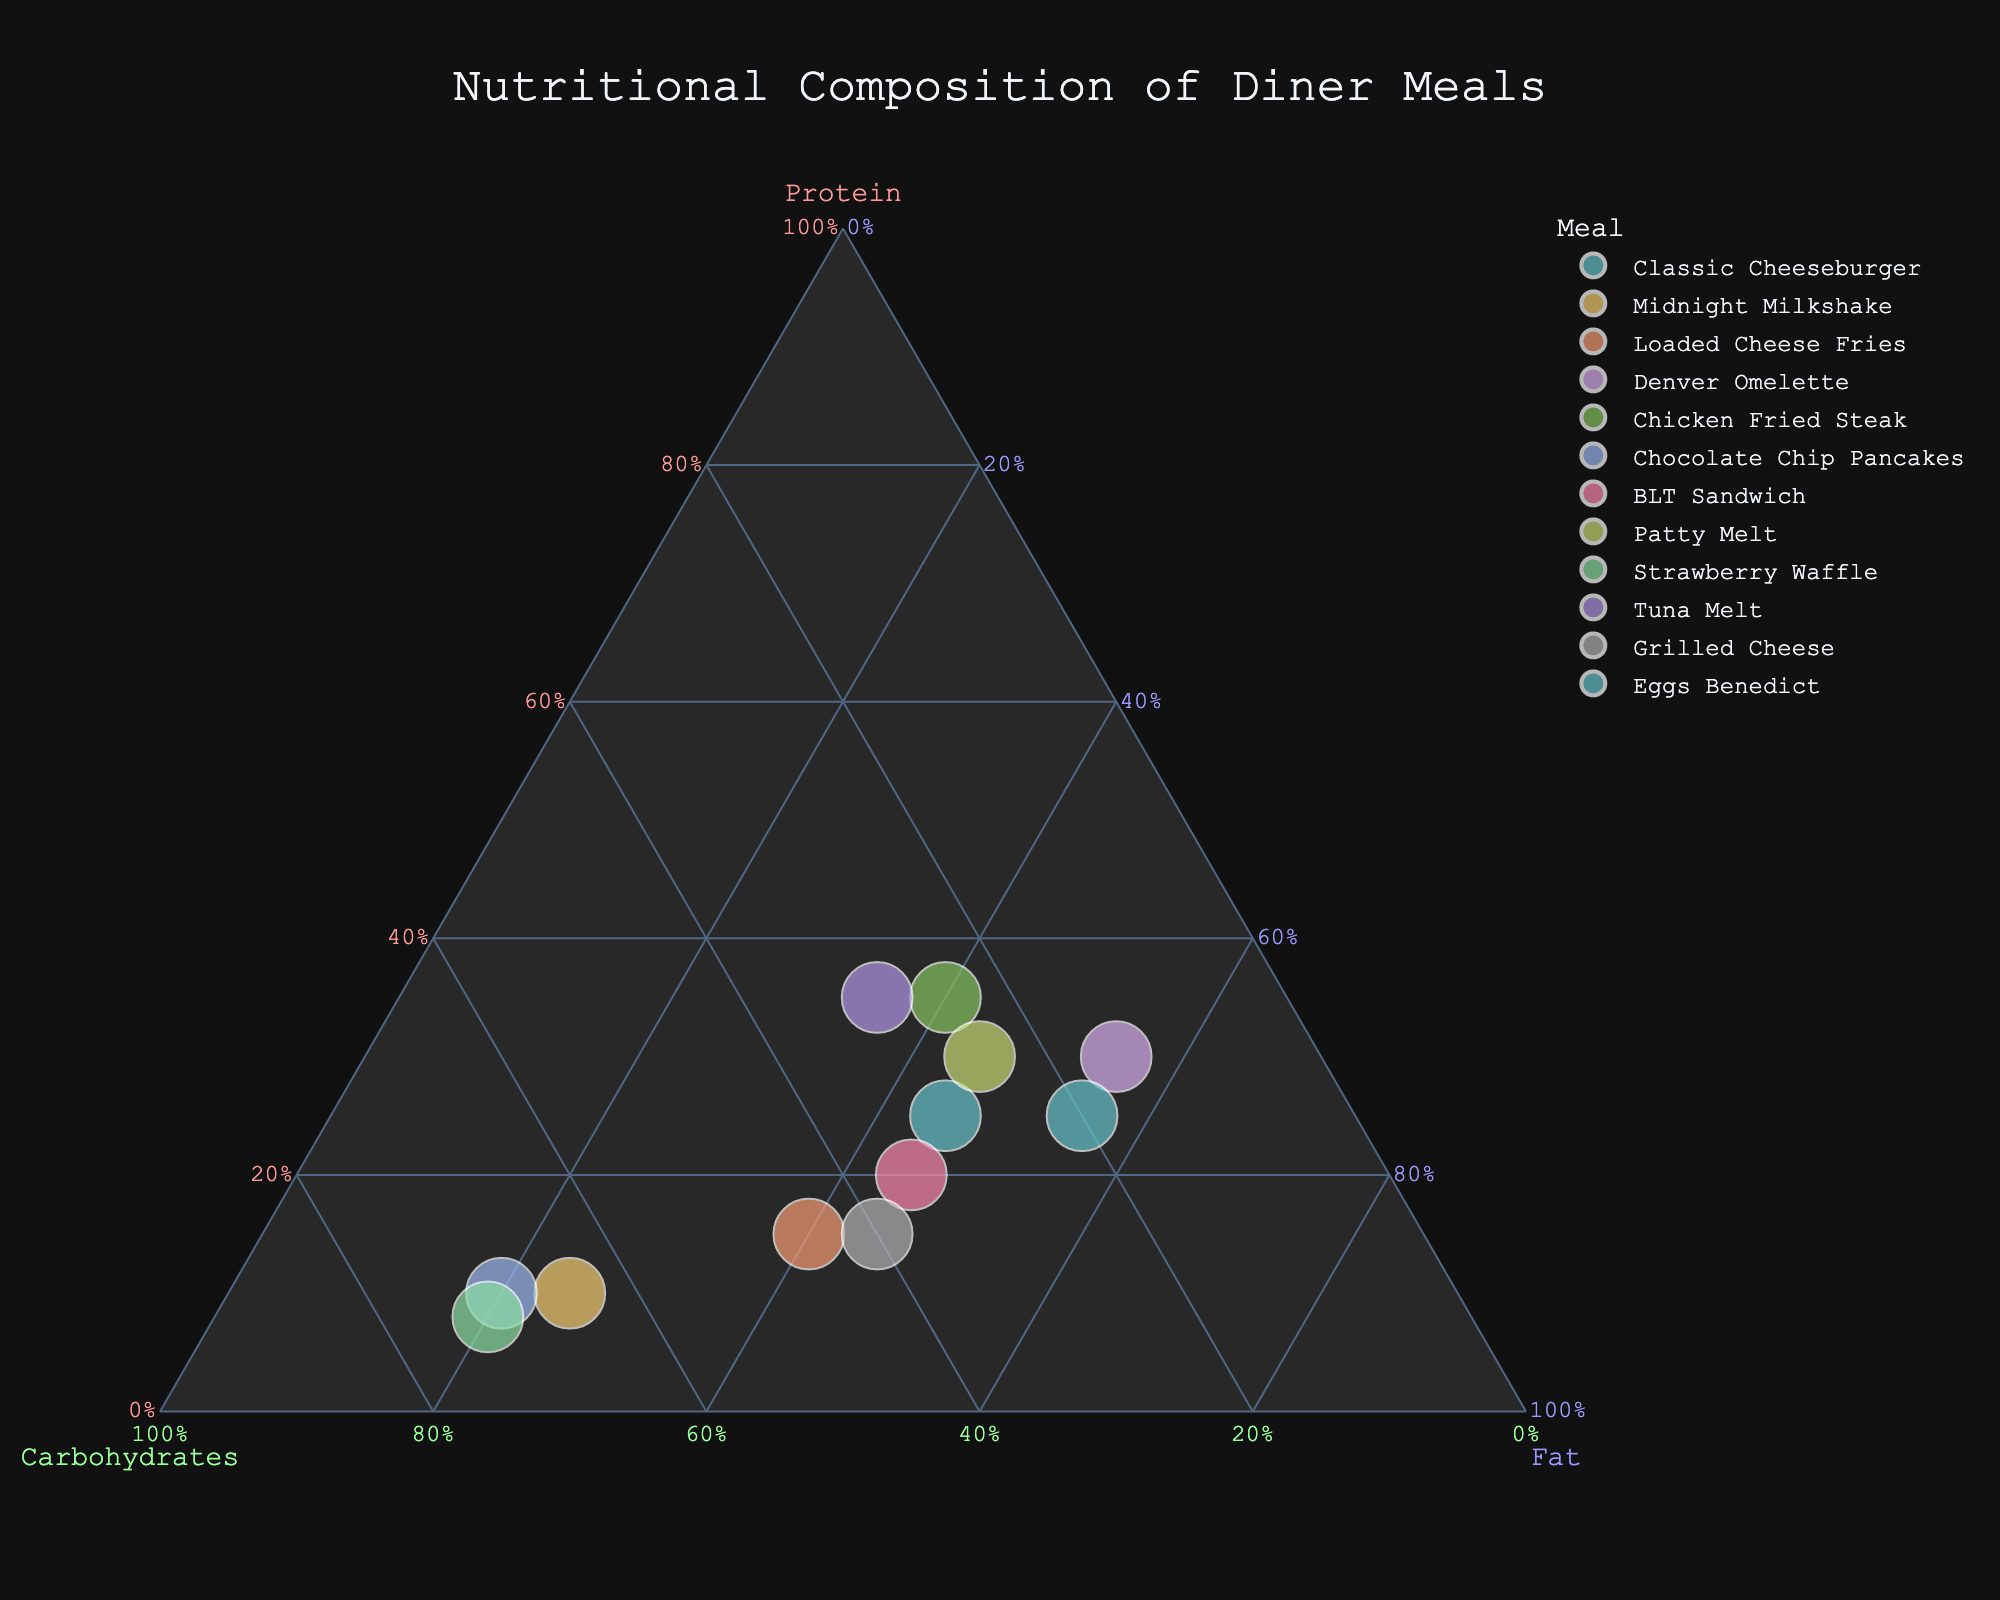What's the title of the plot? The title is displayed prominently at the top of the figure. It summarizes the overall subject of the plot, making it easy to identify the theme of the visualization.
Answer: Nutritional Composition of Diner Meals How many meals are represented on the plot? Each meal corresponds to a distinct point plotted on the ternary diagram, and each point is colored differently. By counting these points, you can determine the total number of meals.
Answer: 12 Which meal has the highest proportion of carbohydrates? To determine this, locate the point closest to the 'Carbohydrates' axis. The farther a point is from the 'Carbohydrates' axis, the higher its carbohydrate content.
Answer: Strawberry Waffle What is the relative composition of protein, carbohydrates, and fat in the Classic Cheeseburger? Hovering over the point for Classic Cheeseburger will show its precise proportions for protein, carbohydrates, and fat. The data is displayed as percentages.
Answer: Protein: 25%, Carbohydrates: 30%, Fat: 45% Which meal has the largest total nutrient content (g)? The size of each point indicates the total nutrient content. The meal with the largest point has the highest total nutrient content.
Answer: Chicken Fried Steak Compare the carbohydrate content of Midnight Milkshake and Chocolate Chip Pancakes. Which one has more carbohydrates? Locate both points on the plot. Midnight Milkshake and Chocolate Chip Pancakes are positioned based on their carbohydrate content. By comparing their positions relative to the 'Carbohydrates' axis, you can see which one is closer to it, indicating higher carbohydrate content.
Answer: Chocolate Chip Pancakes Are there any meals with equal proportions of protein and fat? If so, which one(s)? To find meals with equal protein and fat proportions, look for points equidistant from the 'Protein' and 'Fat' axes. These points will lie along the bisector line between these two axes.
Answer: Patty Melt, Eggs Benedict What is the difference in protein content between Denver Omelette and BLT Sandwich? Find the points for both Denver Omelette and BLT Sandwich. Hover over them to see their exact protein proportions. Subtract the protein proportion of BLT Sandwich from that of Denver Omelette.
Answer: 10% How does the Strawberry Waffle compare in its fat proportion against the Grilled Cheese? Locate both points on the plot. By examining their positions relative to the 'Fat' axis, identify which is closer to it. It will show which one has a higher fat proportion.
Answer: They are equal Which meal has the smallest total nutrient content (g), and what are its proportions? The smallest point on the plot represents the meal with the least total nutrient content. Identify this point and examine its hover text to understand its proportions of protein, carbohydrates, and fat.
Answer: Strawberry Waffle, Protein: 8%, Carbohydrates: 72%, Fat: 20% 